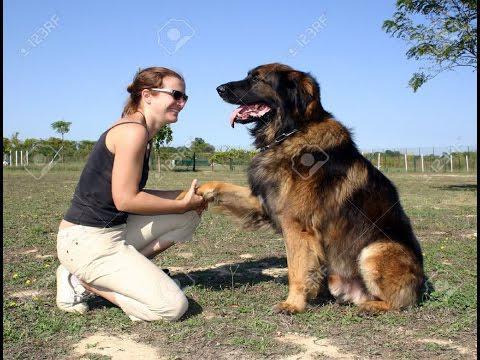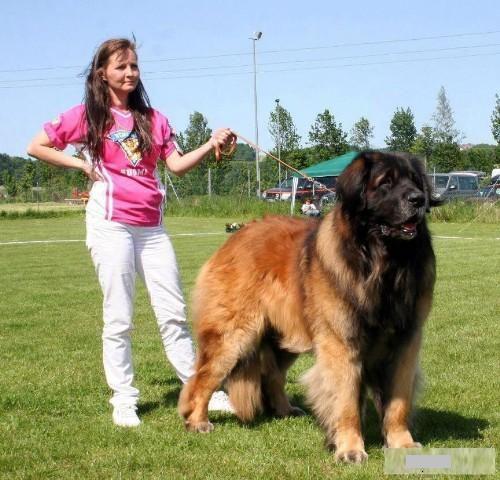The first image is the image on the left, the second image is the image on the right. Considering the images on both sides, is "A person is touching a dog" valid? Answer yes or no. Yes. 